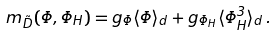<formula> <loc_0><loc_0><loc_500><loc_500>m _ { \tilde { D } } ( \Phi , \Phi _ { H } ) = g _ { \Phi } \langle \Phi \rangle _ { d } + g _ { \Phi _ { H } } \langle \Phi _ { H } ^ { 3 } \rangle _ { d } \, .</formula> 